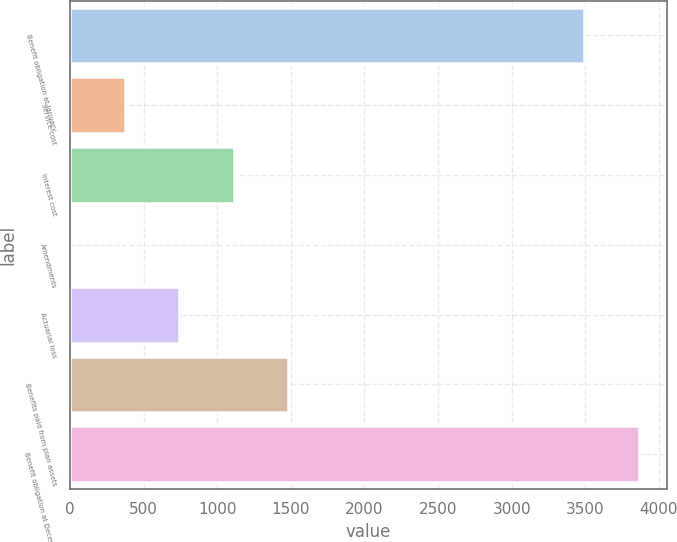Convert chart. <chart><loc_0><loc_0><loc_500><loc_500><bar_chart><fcel>Benefit obligation at January<fcel>Service cost<fcel>Interest cost<fcel>Amendments<fcel>Actuarial loss<fcel>Benefits paid from plan assets<fcel>Benefit obligation at December<nl><fcel>3492.7<fcel>370.17<fcel>1110.31<fcel>0.1<fcel>740.24<fcel>1480.38<fcel>3862.77<nl></chart> 